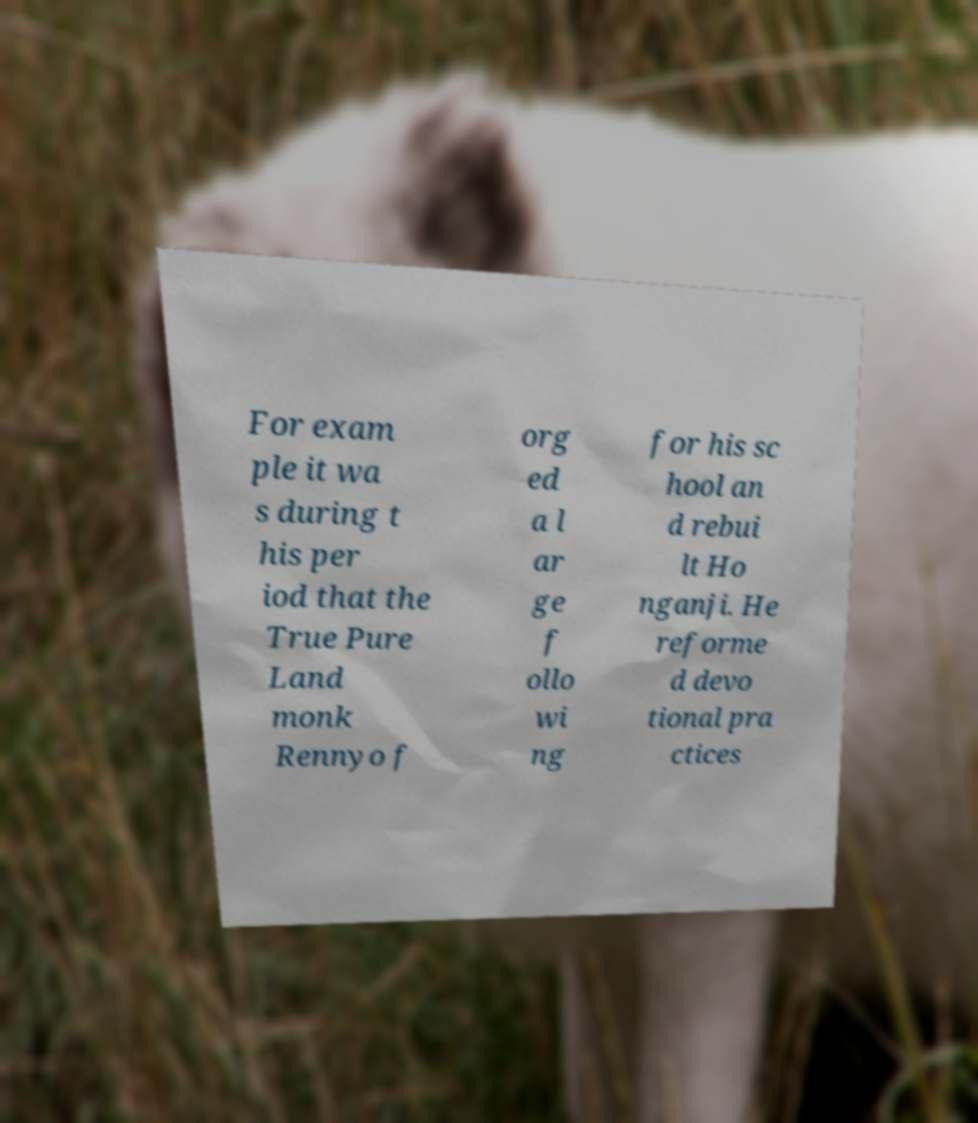There's text embedded in this image that I need extracted. Can you transcribe it verbatim? For exam ple it wa s during t his per iod that the True Pure Land monk Rennyo f org ed a l ar ge f ollo wi ng for his sc hool an d rebui lt Ho nganji. He reforme d devo tional pra ctices 